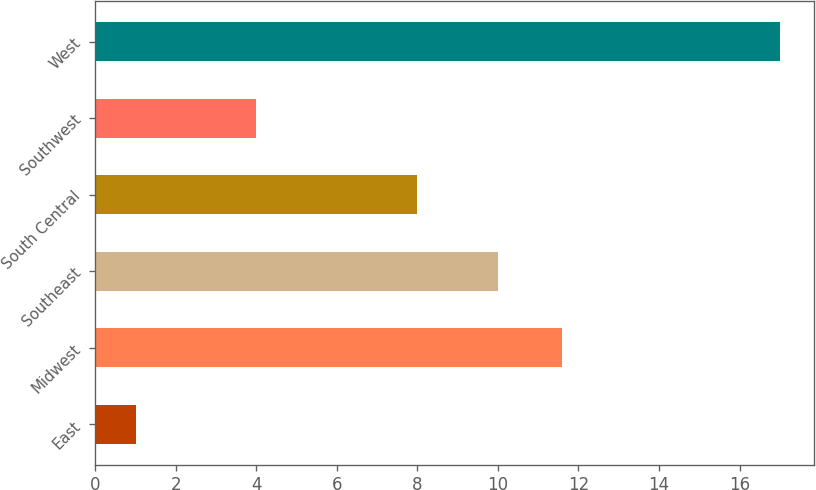<chart> <loc_0><loc_0><loc_500><loc_500><bar_chart><fcel>East<fcel>Midwest<fcel>Southeast<fcel>South Central<fcel>Southwest<fcel>West<nl><fcel>1<fcel>11.6<fcel>10<fcel>8<fcel>4<fcel>17<nl></chart> 